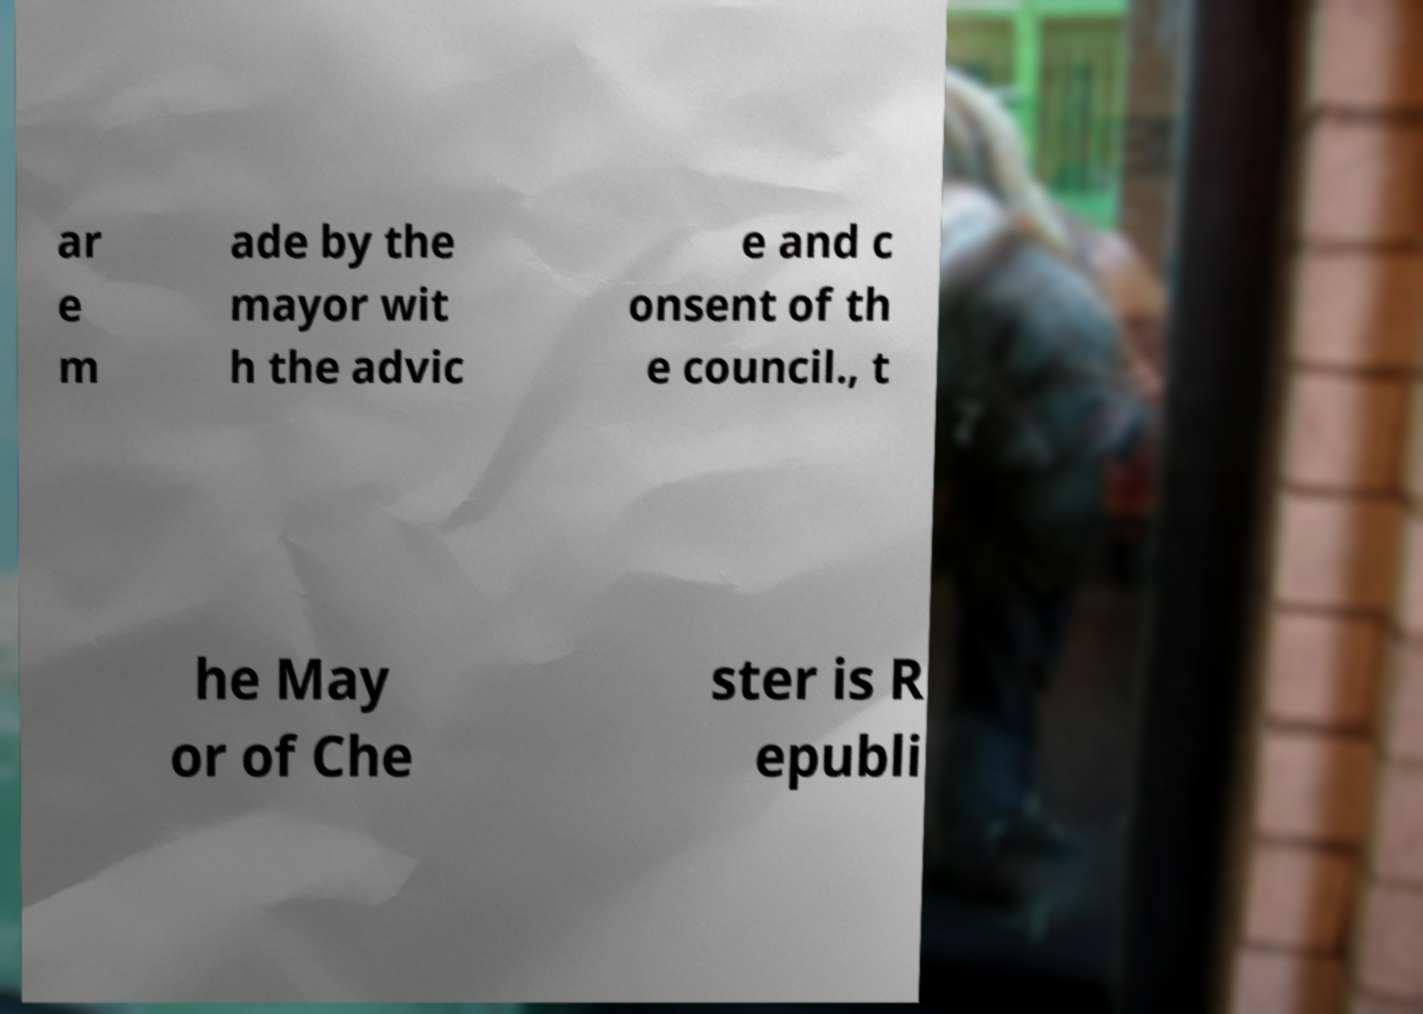Please identify and transcribe the text found in this image. ar e m ade by the mayor wit h the advic e and c onsent of th e council., t he May or of Che ster is R epubli 